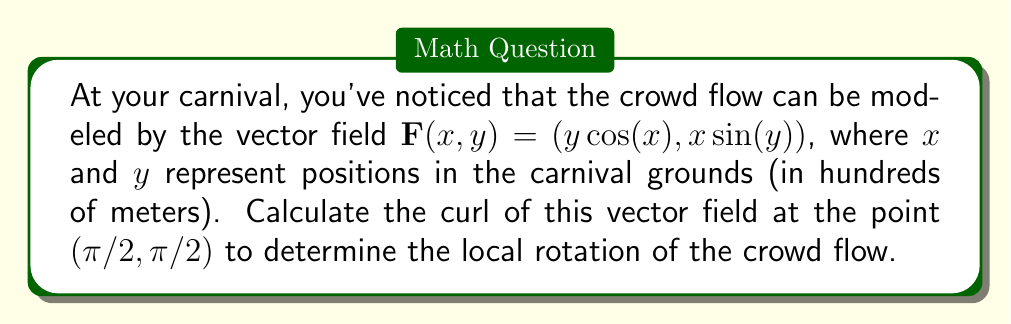Solve this math problem. To find the curl of the vector field $\mathbf{F}(x,y) = (y\cos(x), x\sin(y))$ at the point $(π/2, π/2)$, we follow these steps:

1) The curl of a 2D vector field $\mathbf{F}(x,y) = (P(x,y), Q(x,y))$ is given by:

   $$\text{curl}\mathbf{F} = \frac{\partial Q}{\partial x} - \frac{\partial P}{\partial y}$$

2) In our case, $P(x,y) = y\cos(x)$ and $Q(x,y) = x\sin(y)$

3) Let's calculate the partial derivatives:

   $$\frac{\partial Q}{\partial x} = \sin(y)$$
   
   $$\frac{\partial P}{\partial y} = \cos(x)$$

4) Now, we can compute the curl:

   $$\text{curl}\mathbf{F} = \sin(y) - \cos(x)$$

5) Evaluate this at the point $(π/2, π/2)$:

   $$\text{curl}\mathbf{F}(π/2, π/2) = \sin(π/2) - \cos(π/2) = 1 - 0 = 1$$

Therefore, the curl of the vector field at $(π/2, π/2)$ is 1, indicating a counterclockwise rotation in the crowd flow at this point.
Answer: 1 